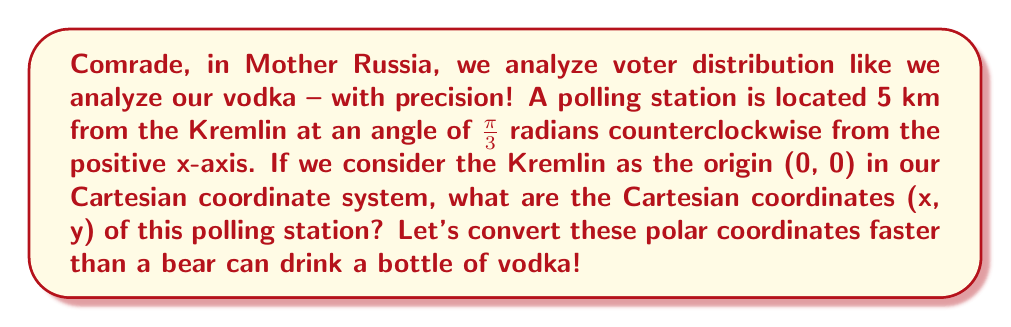Provide a solution to this math problem. To convert polar coordinates $(r, \theta)$ to Cartesian coordinates $(x, y)$, we use the following formulas:

$$x = r \cos(\theta)$$
$$y = r \sin(\theta)$$

Given:
- $r = 5$ km (distance from the Kremlin)
- $\theta = \frac{\pi}{3}$ radians (angle from the positive x-axis)

Let's calculate step by step:

1. Calculate x-coordinate:
   $$x = 5 \cos(\frac{\pi}{3})$$
   $$x = 5 \cdot \frac{1}{2} = 2.5$$ km

2. Calculate y-coordinate:
   $$y = 5 \sin(\frac{\pi}{3})$$
   $$y = 5 \cdot \frac{\sqrt{3}}{2} = 5 \cdot \frac{\sqrt{3}}{2} \approx 4.33$$ km

Therefore, the Cartesian coordinates of the polling station are approximately (2.5, 4.33) km.

[asy]
import geometry;

unitsize(1cm);

draw((-1,0)--(6,0), arrow=Arrow(TeXHead));
draw((0,-1)--(0,6), arrow=Arrow(TeXHead));

dot((0,0), L="Kremlin");
dot((2.5,4.33), L="Polling Station");

draw((0,0)--(2.5,4.33), arrow=Arrow(TeXHead));
draw(arc((0,0), 1, 0, 60), L="$\frac{\pi}{3}$");

label("x", (6,0), E);
label("y", (0,6), N);
label("5 km", (1.25,2.165), NW);
[/asy]
Answer: The Cartesian coordinates of the polling station are approximately (2.5, 4.33) km from the Kremlin. 